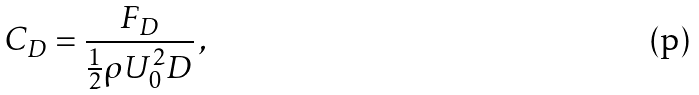<formula> <loc_0><loc_0><loc_500><loc_500>C _ { D } = \frac { F _ { D } } { \frac { 1 } { 2 } \rho U _ { 0 } ^ { 2 } D } \, ,</formula> 